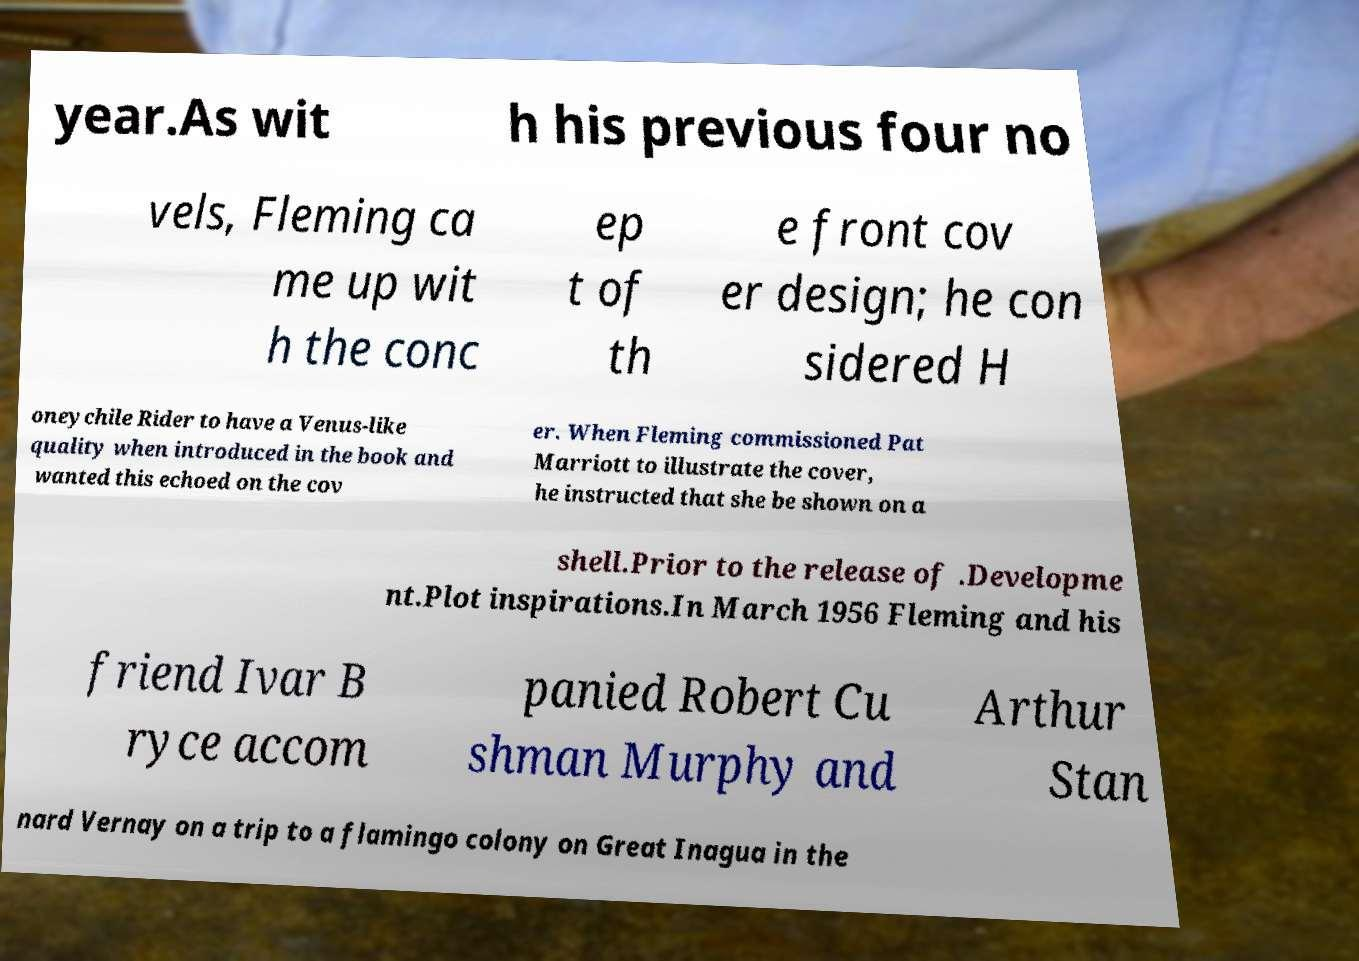Please read and relay the text visible in this image. What does it say? year.As wit h his previous four no vels, Fleming ca me up wit h the conc ep t of th e front cov er design; he con sidered H oneychile Rider to have a Venus-like quality when introduced in the book and wanted this echoed on the cov er. When Fleming commissioned Pat Marriott to illustrate the cover, he instructed that she be shown on a shell.Prior to the release of .Developme nt.Plot inspirations.In March 1956 Fleming and his friend Ivar B ryce accom panied Robert Cu shman Murphy and Arthur Stan nard Vernay on a trip to a flamingo colony on Great Inagua in the 